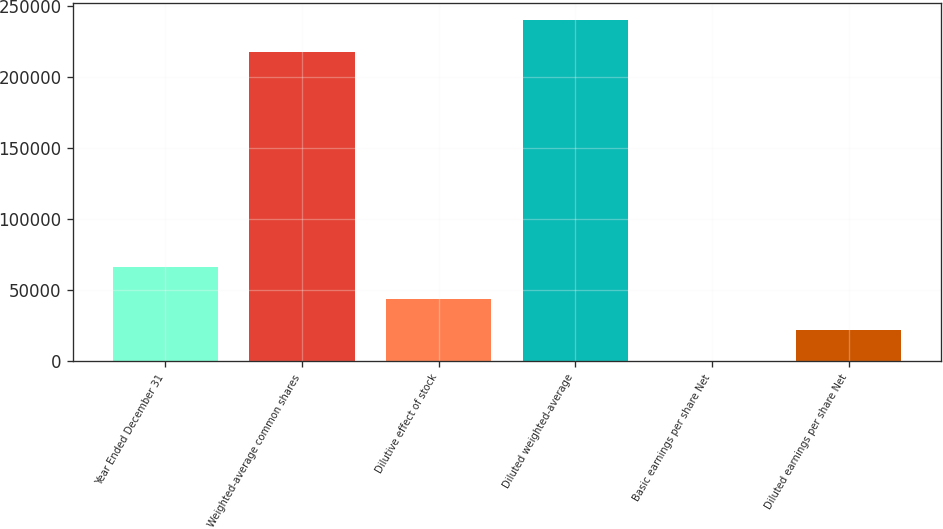Convert chart. <chart><loc_0><loc_0><loc_500><loc_500><bar_chart><fcel>Year Ended December 31<fcel>Weighted-average common shares<fcel>Dilutive effect of stock<fcel>Diluted weighted-average<fcel>Basic earnings per share Net<fcel>Diluted earnings per share Net<nl><fcel>65837.1<fcel>217930<fcel>43891.5<fcel>239876<fcel>0.08<fcel>21945.8<nl></chart> 